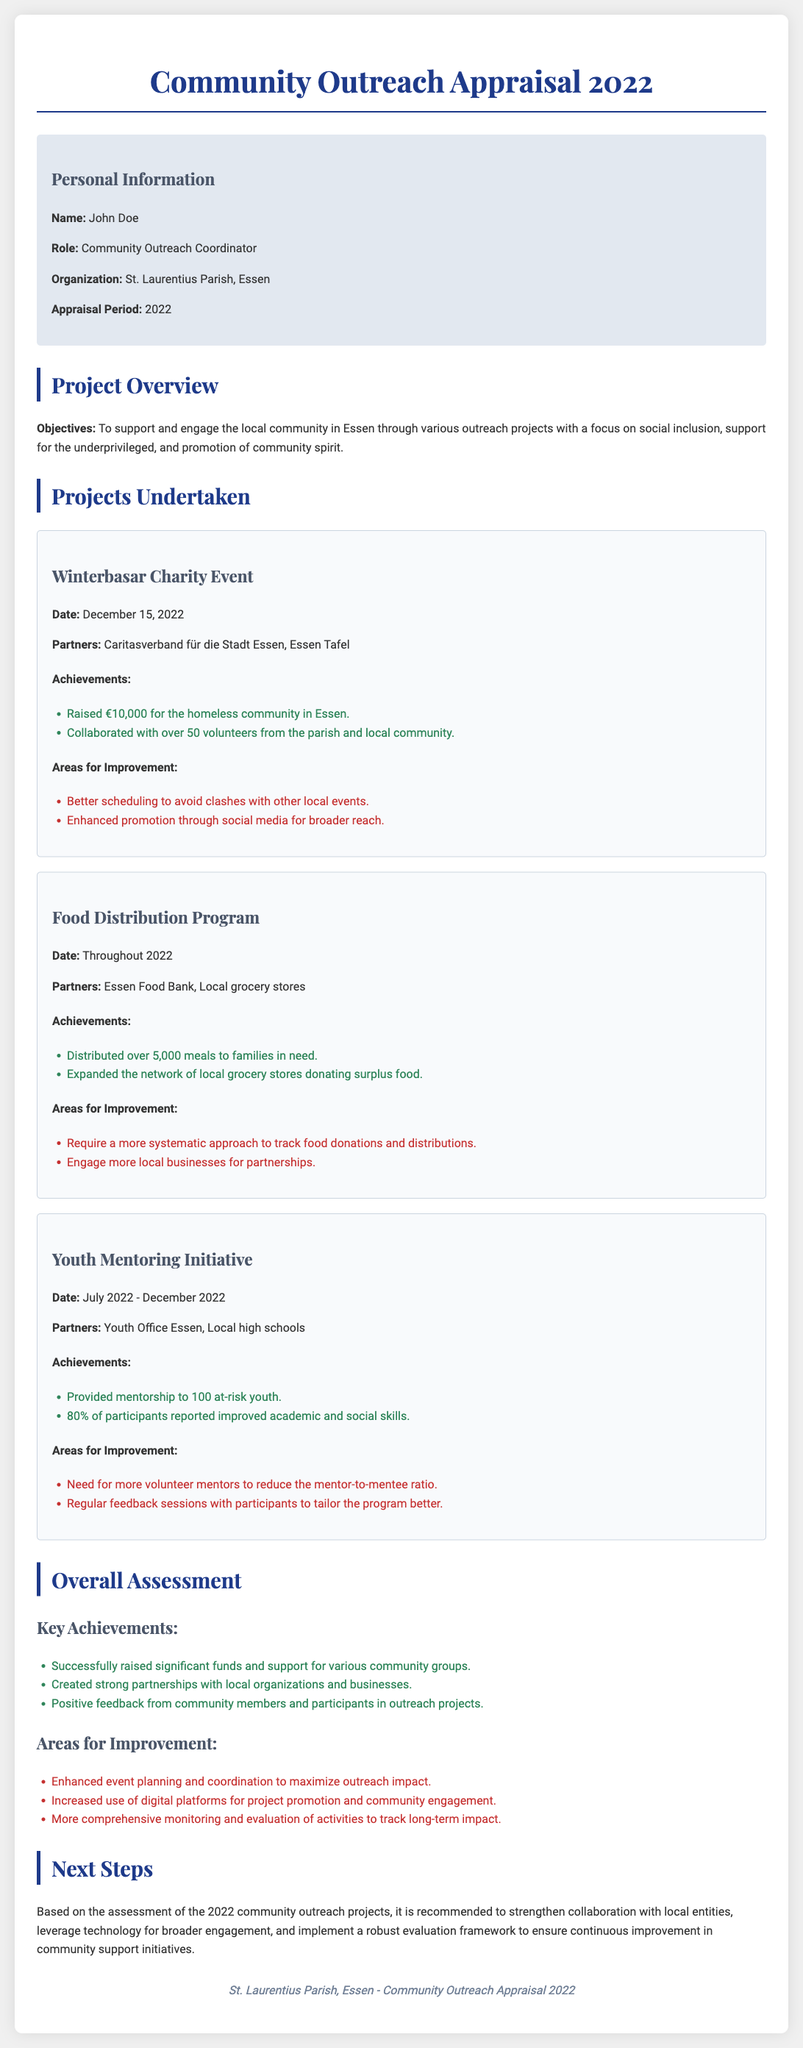What is the name of the community outreach coordinator? The name of the community outreach coordinator is mentioned in the personal information section.
Answer: John Doe What was the date of the Winterbasar Charity Event? The event date is provided under the project details for the Winterbasar Charity Event.
Answer: December 15, 2022 How much money was raised for the homeless community? The amount raised is clearly listed under the achievements of the Winterbasar Charity Event.
Answer: €10,000 How many meals were distributed in the Food Distribution Program? This number is specified in the achievements of the Food Distribution Program.
Answer: 5,000 meals What percentage of participants reported improved skills in the Youth Mentoring Initiative? The percentage is stated in the achievements section for the Youth Mentoring Initiative.
Answer: 80% What is one area suggested for improvement in the overall assessment? Areas for improvement are listed under the overall assessment section, focusing on suggestions for enhancement.
Answer: Enhanced event planning Which partners were involved in the Food Distribution Program? Partners are mentioned in the project details for the Food Distribution Program.
Answer: Essen Food Bank, Local grocery stores What did the Youth Mentoring Initiative focus on? The focus of the initiative is inferred from the objectives and achievements described in the document.
Answer: Mentorship for at-risk youth How many volunteers participated in the Winterbasar event? The number of volunteers involved is detailed in the achievements of the Winterbasar Charity Event.
Answer: Over 50 volunteers 